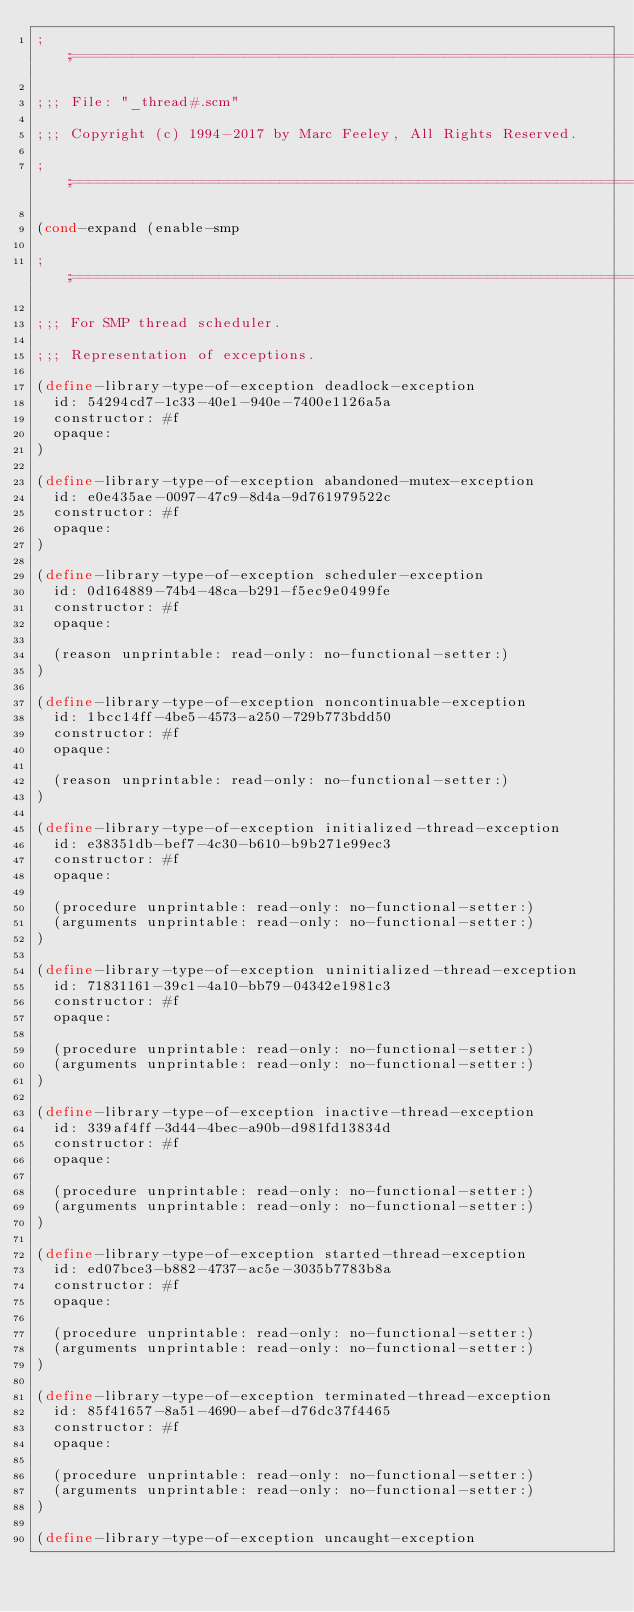Convert code to text. <code><loc_0><loc_0><loc_500><loc_500><_Scheme_>;;;============================================================================

;;; File: "_thread#.scm"

;;; Copyright (c) 1994-2017 by Marc Feeley, All Rights Reserved.

;;;============================================================================

(cond-expand (enable-smp

;;;============================================================================

;;; For SMP thread scheduler.

;;; Representation of exceptions.

(define-library-type-of-exception deadlock-exception
  id: 54294cd7-1c33-40e1-940e-7400e1126a5a
  constructor: #f
  opaque:
)

(define-library-type-of-exception abandoned-mutex-exception
  id: e0e435ae-0097-47c9-8d4a-9d761979522c
  constructor: #f
  opaque:
)

(define-library-type-of-exception scheduler-exception
  id: 0d164889-74b4-48ca-b291-f5ec9e0499fe
  constructor: #f
  opaque:

  (reason unprintable: read-only: no-functional-setter:)
)

(define-library-type-of-exception noncontinuable-exception
  id: 1bcc14ff-4be5-4573-a250-729b773bdd50
  constructor: #f
  opaque:

  (reason unprintable: read-only: no-functional-setter:)
)

(define-library-type-of-exception initialized-thread-exception
  id: e38351db-bef7-4c30-b610-b9b271e99ec3
  constructor: #f
  opaque:

  (procedure unprintable: read-only: no-functional-setter:)
  (arguments unprintable: read-only: no-functional-setter:)
)

(define-library-type-of-exception uninitialized-thread-exception
  id: 71831161-39c1-4a10-bb79-04342e1981c3
  constructor: #f
  opaque:

  (procedure unprintable: read-only: no-functional-setter:)
  (arguments unprintable: read-only: no-functional-setter:)
)

(define-library-type-of-exception inactive-thread-exception
  id: 339af4ff-3d44-4bec-a90b-d981fd13834d
  constructor: #f
  opaque:

  (procedure unprintable: read-only: no-functional-setter:)
  (arguments unprintable: read-only: no-functional-setter:)
)

(define-library-type-of-exception started-thread-exception
  id: ed07bce3-b882-4737-ac5e-3035b7783b8a
  constructor: #f
  opaque:

  (procedure unprintable: read-only: no-functional-setter:)
  (arguments unprintable: read-only: no-functional-setter:)
)

(define-library-type-of-exception terminated-thread-exception
  id: 85f41657-8a51-4690-abef-d76dc37f4465
  constructor: #f
  opaque:

  (procedure unprintable: read-only: no-functional-setter:)
  (arguments unprintable: read-only: no-functional-setter:)
)

(define-library-type-of-exception uncaught-exception</code> 